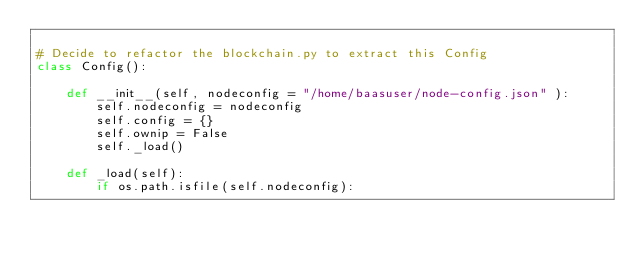<code> <loc_0><loc_0><loc_500><loc_500><_Python_>
# Decide to refactor the blockchain.py to extract this Config
class Config():

    def __init__(self, nodeconfig = "/home/baasuser/node-config.json" ):
        self.nodeconfig = nodeconfig
        self.config = {}
        self.ownip = False
        self._load()

    def _load(self):
        if os.path.isfile(self.nodeconfig):</code> 